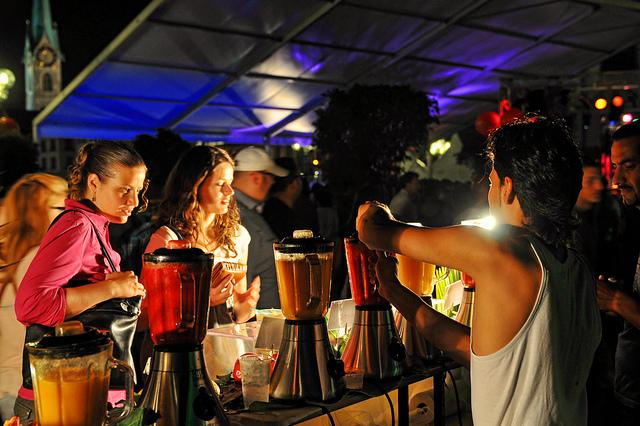What is the boy doing?

Choices:
A) selling juice
B) selling blenders
C) food demonstration
D) playing magoc selling juice 